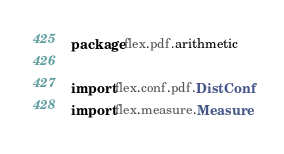Convert code to text. <code><loc_0><loc_0><loc_500><loc_500><_Scala_>package flex.pdf.arithmetic

import flex.conf.pdf.DistConf
import flex.measure.Measure</code> 